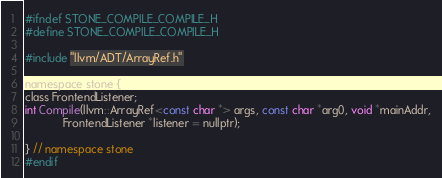<code> <loc_0><loc_0><loc_500><loc_500><_C_>#ifndef STONE_COMPILE_COMPILE_H
#define STONE_COMPILE_COMPILE_H

#include "llvm/ADT/ArrayRef.h"

namespace stone {
class FrontendListener;
int Compile(llvm::ArrayRef<const char *> args, const char *arg0, void *mainAddr,
            FrontendListener *listener = nullptr);

} // namespace stone
#endif
</code> 